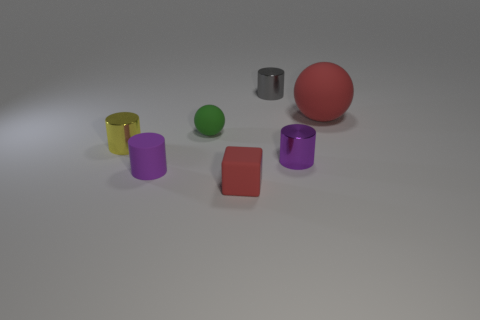Are there fewer gray metal cylinders in front of the big matte thing than purple things on the left side of the purple rubber cylinder?
Provide a short and direct response. No. Is the size of the yellow shiny object the same as the gray object?
Make the answer very short. Yes. There is a tiny metallic object that is both in front of the green ball and to the right of the matte cylinder; what is its shape?
Offer a very short reply. Cylinder. How many other gray things are the same material as the big thing?
Ensure brevity in your answer.  0. What number of metal cylinders are behind the tiny shiny cylinder that is behind the yellow object?
Provide a short and direct response. 0. What is the shape of the red rubber object that is behind the tiny purple thing on the left side of the red thing that is in front of the purple shiny cylinder?
Provide a succinct answer. Sphere. There is a ball that is the same color as the tiny block; what is its size?
Your answer should be very brief. Large. What number of things are metallic objects or tiny cyan rubber things?
Provide a short and direct response. 3. What color is the ball that is the same size as the rubber block?
Your response must be concise. Green. Does the big red thing have the same shape as the small matte thing that is behind the purple shiny cylinder?
Make the answer very short. Yes. 